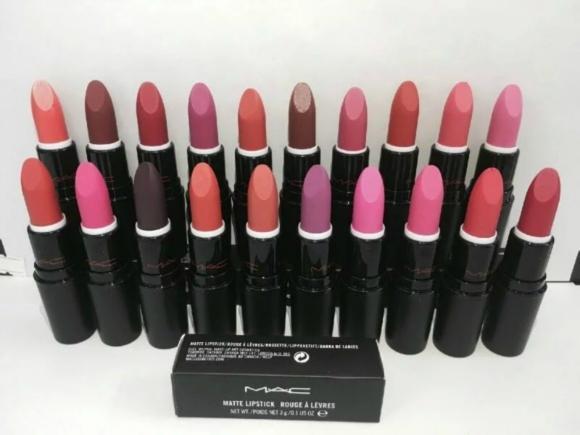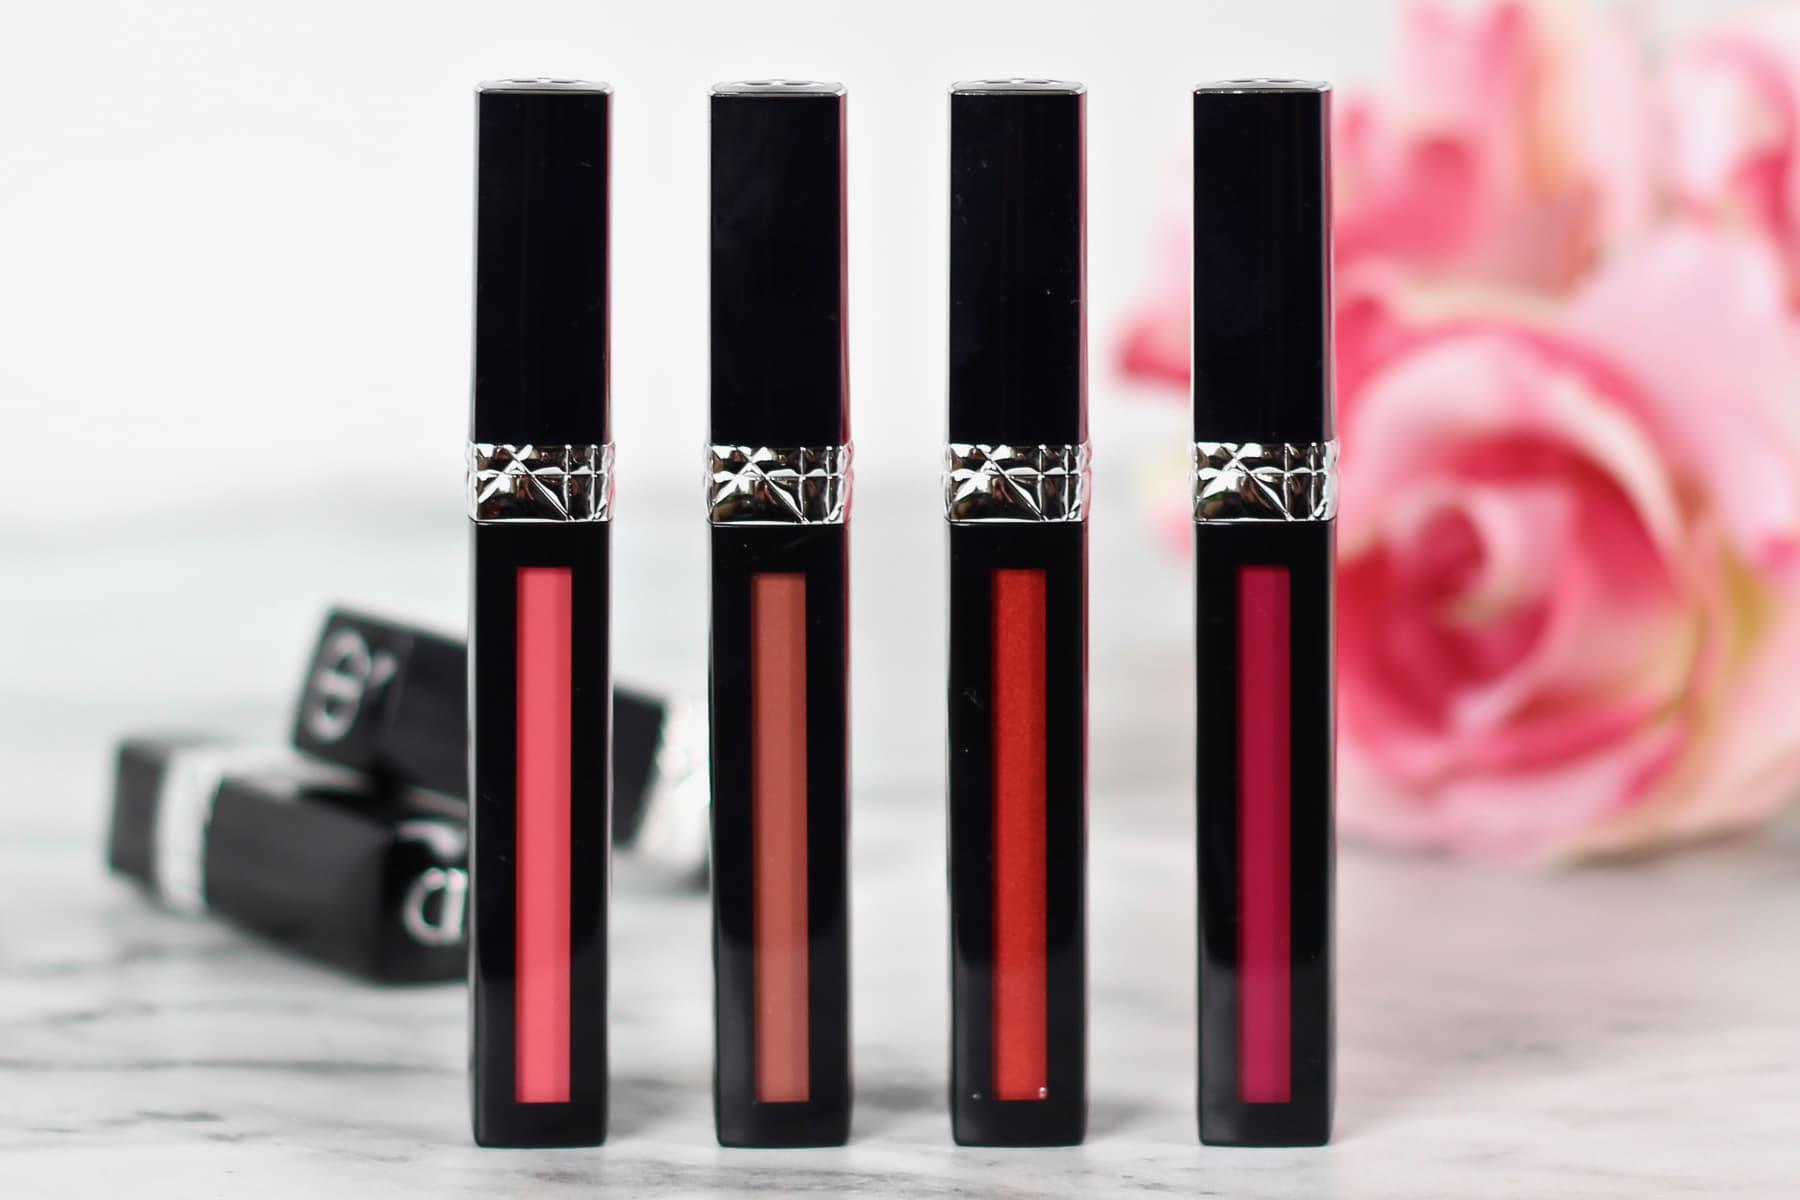The first image is the image on the left, the second image is the image on the right. Evaluate the accuracy of this statement regarding the images: "There is one box in the image on the left.". Is it true? Answer yes or no. Yes. The first image is the image on the left, the second image is the image on the right. Examine the images to the left and right. Is the description "One image shows two rows of lipsticks, with a rectangular box in front of them." accurate? Answer yes or no. Yes. 